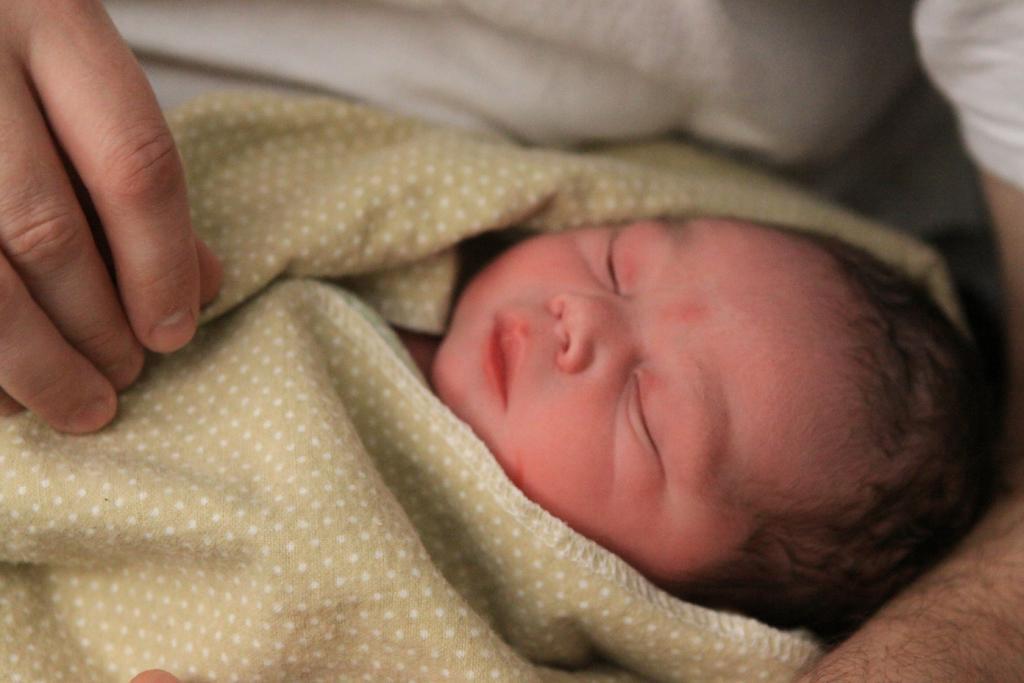How would you summarize this image in a sentence or two? In the image a person is holding a baby. 